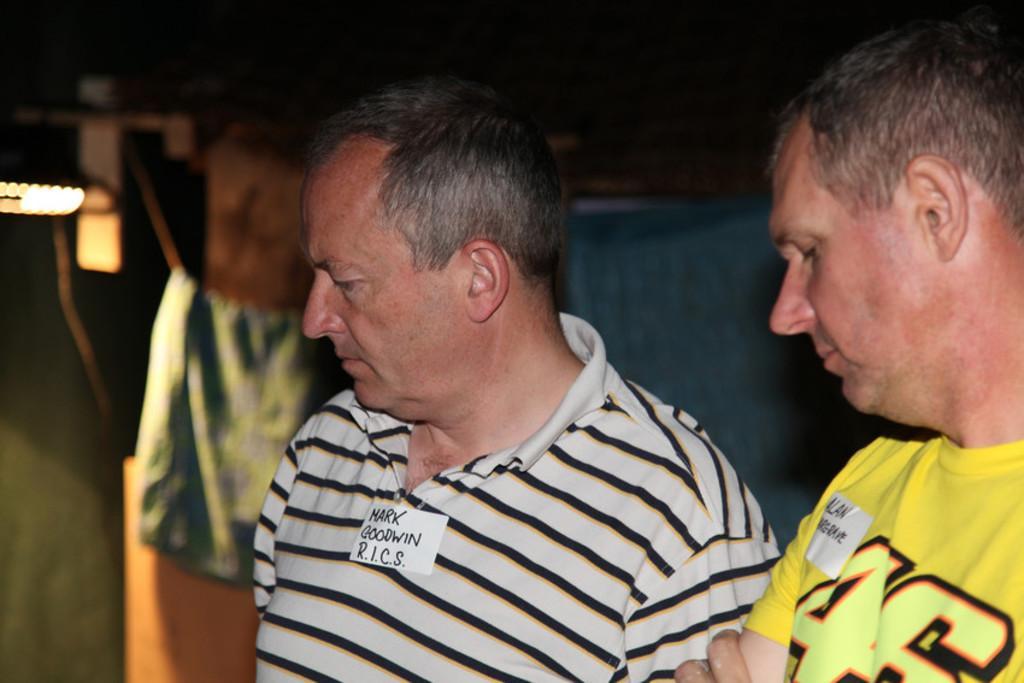Describe this image in one or two sentences. In this image in front there are two persons. Behind them there are few objects. On the left side of the image there is a light. 